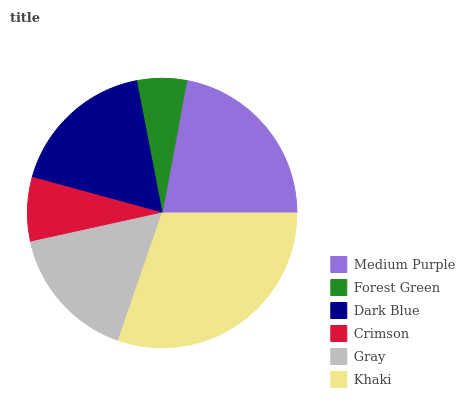Is Forest Green the minimum?
Answer yes or no. Yes. Is Khaki the maximum?
Answer yes or no. Yes. Is Dark Blue the minimum?
Answer yes or no. No. Is Dark Blue the maximum?
Answer yes or no. No. Is Dark Blue greater than Forest Green?
Answer yes or no. Yes. Is Forest Green less than Dark Blue?
Answer yes or no. Yes. Is Forest Green greater than Dark Blue?
Answer yes or no. No. Is Dark Blue less than Forest Green?
Answer yes or no. No. Is Dark Blue the high median?
Answer yes or no. Yes. Is Gray the low median?
Answer yes or no. Yes. Is Medium Purple the high median?
Answer yes or no. No. Is Medium Purple the low median?
Answer yes or no. No. 